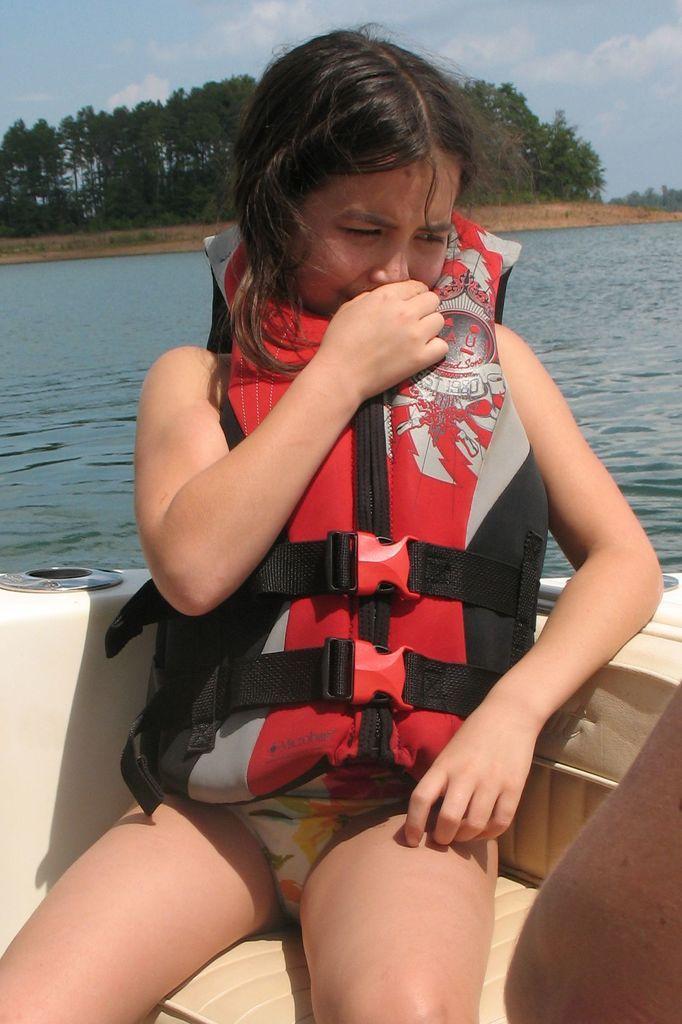Please provide a concise description of this image. In this image in the front there is a girl sitting on the boat and smiling. In the background there is water, there are trees and the sky is cloudy. 